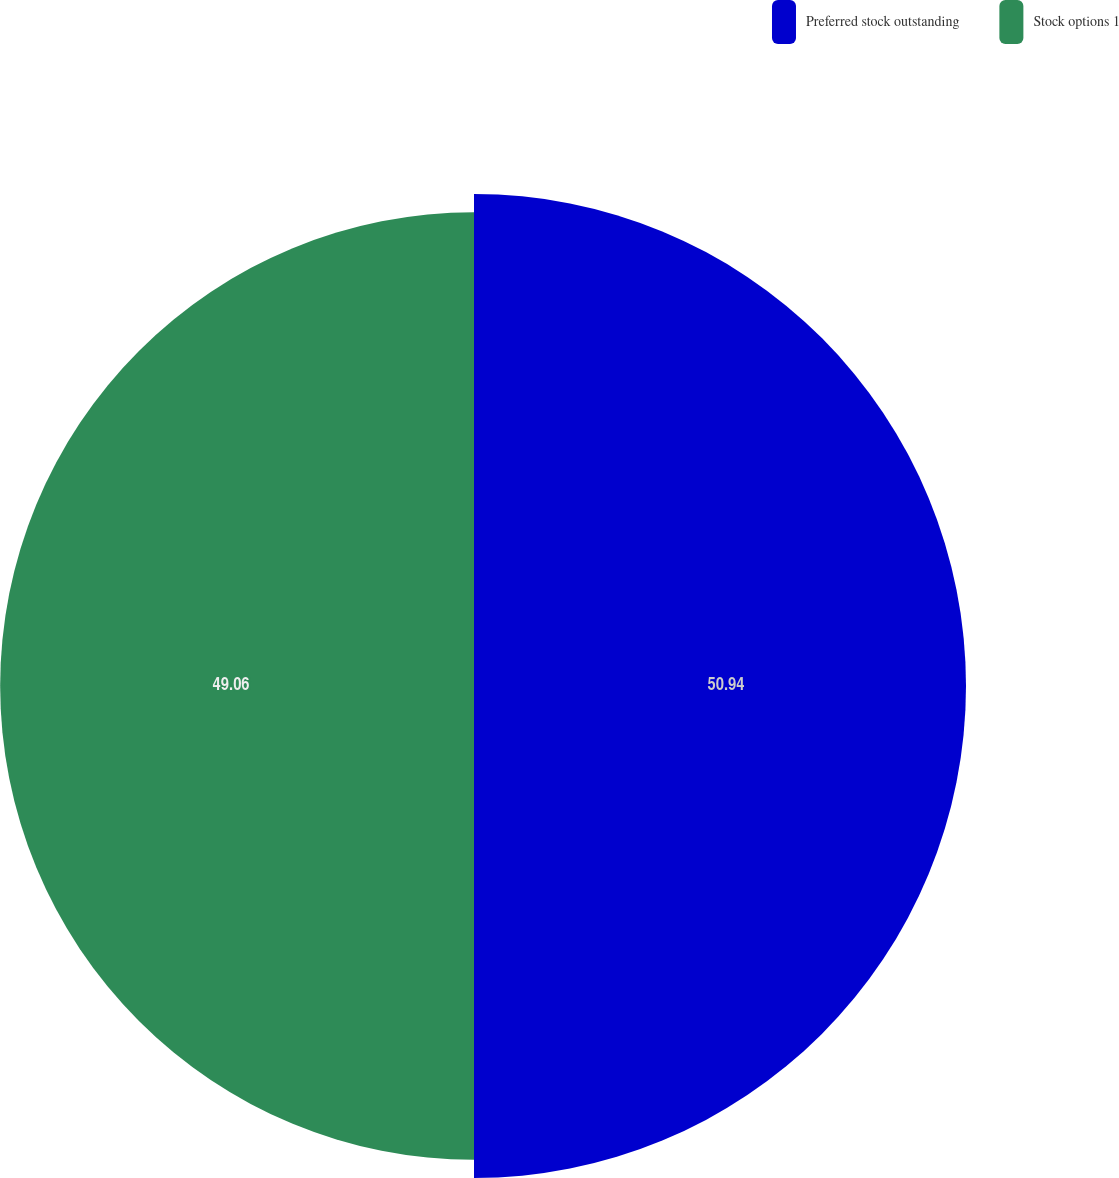Convert chart. <chart><loc_0><loc_0><loc_500><loc_500><pie_chart><fcel>Preferred stock outstanding<fcel>Stock options 1<nl><fcel>50.94%<fcel>49.06%<nl></chart> 